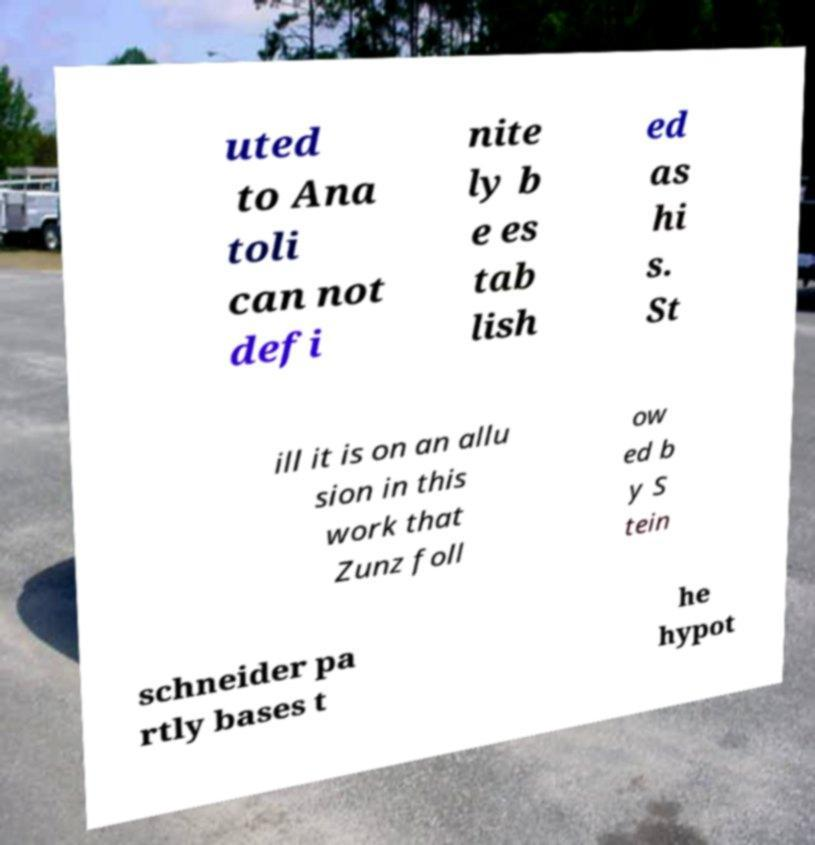Please identify and transcribe the text found in this image. uted to Ana toli can not defi nite ly b e es tab lish ed as hi s. St ill it is on an allu sion in this work that Zunz foll ow ed b y S tein schneider pa rtly bases t he hypot 